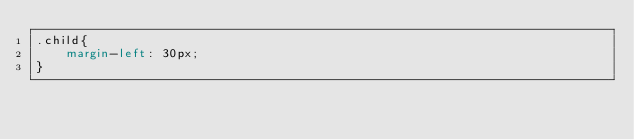<code> <loc_0><loc_0><loc_500><loc_500><_CSS_>.child{
    margin-left: 30px;
}</code> 